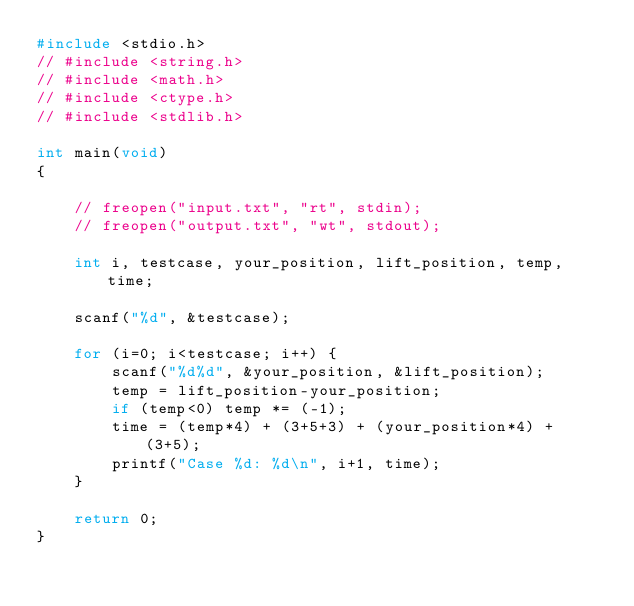Convert code to text. <code><loc_0><loc_0><loc_500><loc_500><_C++_>#include <stdio.h>
// #include <string.h>
// #include <math.h>
// #include <ctype.h>
// #include <stdlib.h>

int main(void) 
{

    // freopen("input.txt", "rt", stdin);
    // freopen("output.txt", "wt", stdout);
    
    int i, testcase, your_position, lift_position, temp, time;

    scanf("%d", &testcase);

    for (i=0; i<testcase; i++) {
        scanf("%d%d", &your_position, &lift_position);
        temp = lift_position-your_position;
        if (temp<0) temp *= (-1);
        time = (temp*4) + (3+5+3) + (your_position*4) + (3+5);
        printf("Case %d: %d\n", i+1, time);
    }

    return 0;
}
</code> 